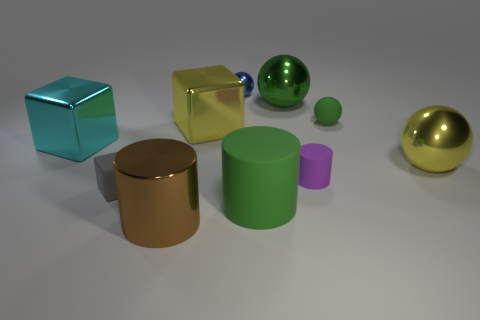Subtract all cylinders. How many objects are left? 7 Subtract 1 green cylinders. How many objects are left? 9 Subtract all gray rubber cylinders. Subtract all green rubber objects. How many objects are left? 8 Add 4 small gray rubber things. How many small gray rubber things are left? 5 Add 5 big shiny things. How many big shiny things exist? 10 